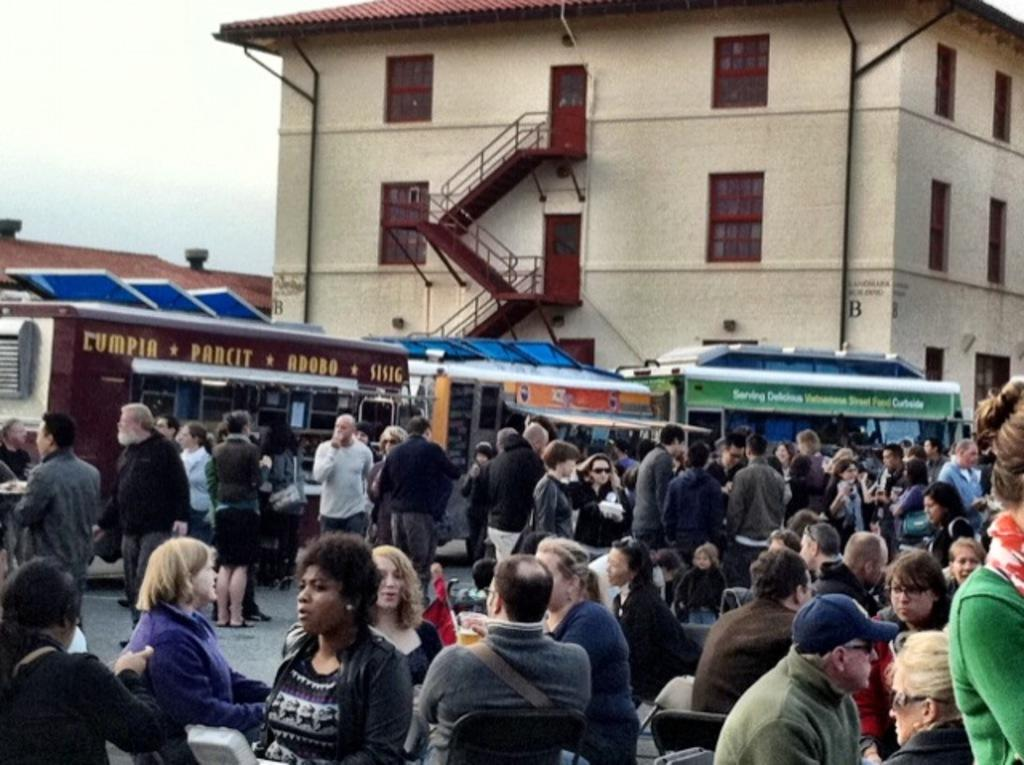What is located at the bottom of the image? There is a crowd at the bottom of the image. What can be seen in the middle of the image? There are buildings in the middle of the image. What is visible in the background of the image? The sky is visible in the background of the image. What type of account is being discussed in the image? There is no account being discussed in the image; it features a crowd, buildings, and the sky. Can you tell me how many kittens are visible in the image? There are no kittens present in the image. 